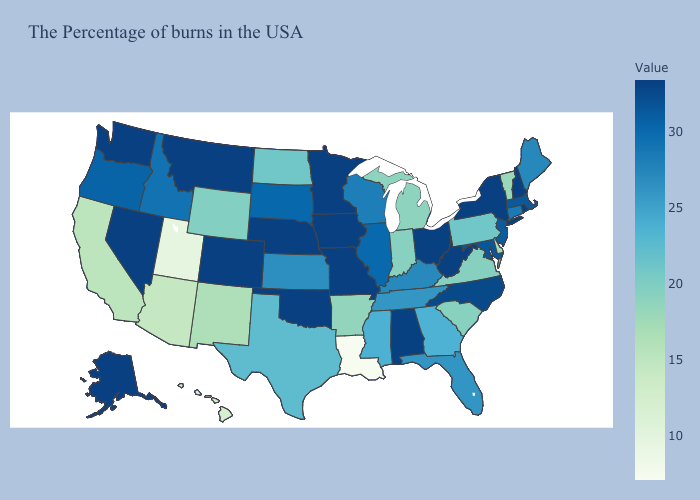Among the states that border Minnesota , does Iowa have the highest value?
Be succinct. Yes. Which states have the lowest value in the South?
Short answer required. Louisiana. Which states hav the highest value in the West?
Answer briefly. Colorado, Montana, Nevada, Washington, Alaska. Does New Mexico have a higher value than Louisiana?
Quick response, please. Yes. Which states hav the highest value in the Northeast?
Concise answer only. Rhode Island, New Hampshire, New York. Does Arkansas have a higher value than Missouri?
Keep it brief. No. Which states have the highest value in the USA?
Quick response, please. Rhode Island, New Hampshire, New York, West Virginia, Ohio, Missouri, Minnesota, Iowa, Nebraska, Oklahoma, Colorado, Montana, Nevada, Washington, Alaska. Does the map have missing data?
Keep it brief. No. 